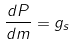<formula> <loc_0><loc_0><loc_500><loc_500>\frac { d P } { d m } = g _ { s }</formula> 